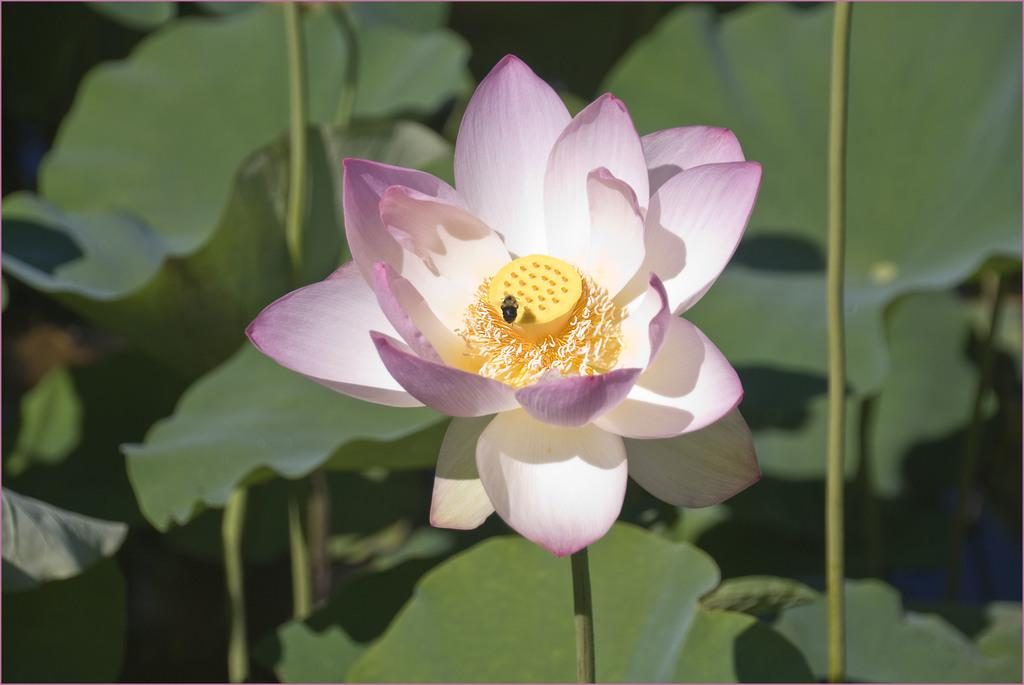What type of flower is in the image? There is a beautiful lotus flower in the image. Is there any other living organism interacting with the flower? Yes, there is a bee on the lotus flower. Can you see the back of the lotus flower in the image? The back of the lotus flower is not visible in the image, as the image only shows the flower from the front. 